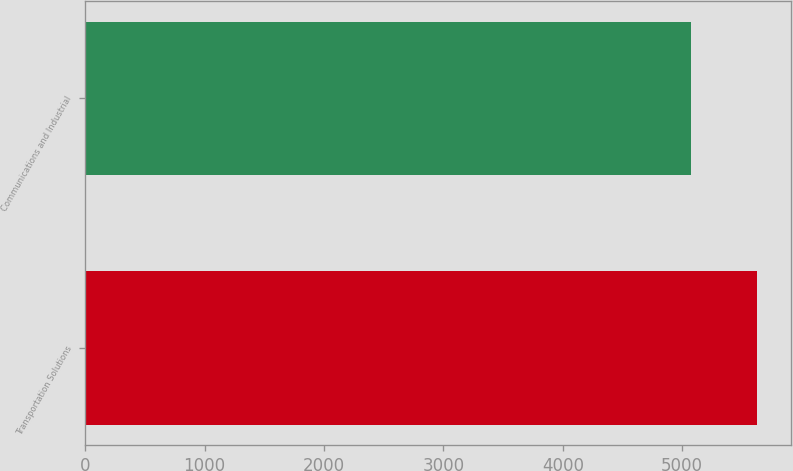Convert chart. <chart><loc_0><loc_0><loc_500><loc_500><bar_chart><fcel>Transportation Solutions<fcel>Communications and Industrial<nl><fcel>5629<fcel>5071<nl></chart> 